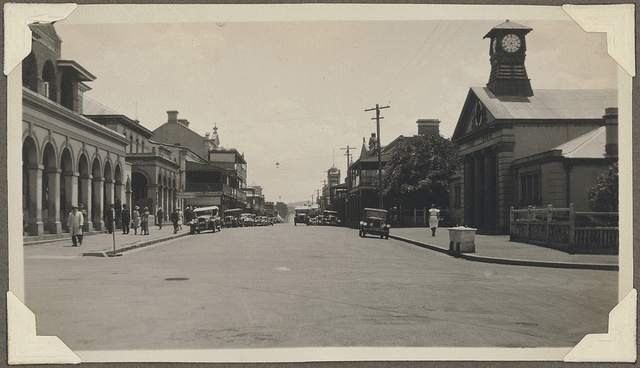Describe the objects in this image and their specific colors. I can see car in gray, black, and darkgray tones, car in gray, black, darkgray, and lightgray tones, people in gray, black, and darkgray tones, car in gray, black, and darkgray tones, and people in gray, black, and darkgray tones in this image. 